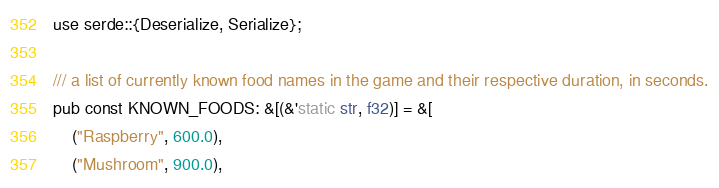Convert code to text. <code><loc_0><loc_0><loc_500><loc_500><_Rust_>use serde::{Deserialize, Serialize};

/// a list of currently known food names in the game and their respective duration, in seconds.
pub const KNOWN_FOODS: &[(&'static str, f32)] = &[
    ("Raspberry", 600.0),
    ("Mushroom", 900.0),</code> 